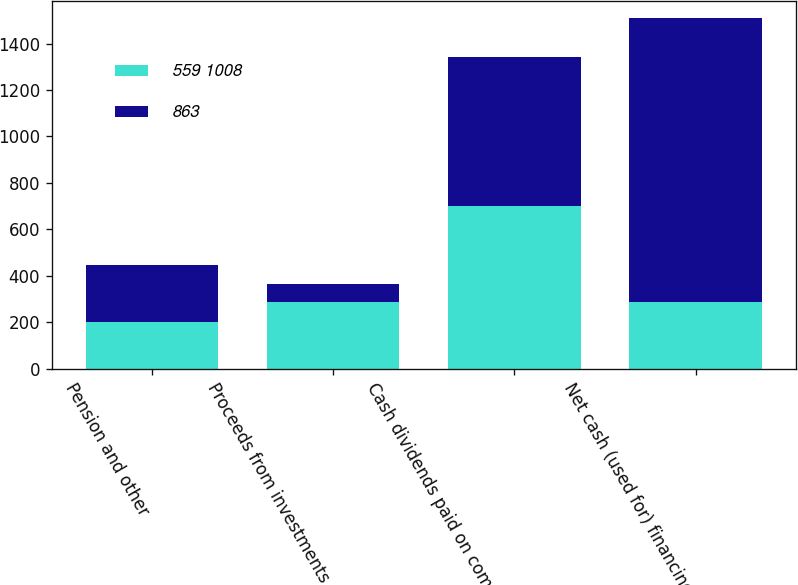Convert chart. <chart><loc_0><loc_0><loc_500><loc_500><stacked_bar_chart><ecel><fcel>Pension and other<fcel>Proceeds from investments<fcel>Cash dividends paid on common<fcel>Net cash (used for) financing<nl><fcel>559 1008<fcel>199<fcel>285<fcel>700<fcel>285<nl><fcel>863<fcel>247<fcel>80<fcel>643<fcel>1223<nl></chart> 